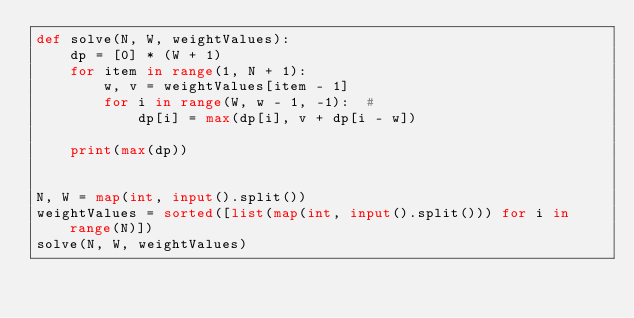<code> <loc_0><loc_0><loc_500><loc_500><_Python_>def solve(N, W, weightValues):
    dp = [0] * (W + 1)
    for item in range(1, N + 1):
        w, v = weightValues[item - 1]
        for i in range(W, w - 1, -1):  #
            dp[i] = max(dp[i], v + dp[i - w])

    print(max(dp))


N, W = map(int, input().split())
weightValues = sorted([list(map(int, input().split())) for i in range(N)])
solve(N, W, weightValues)</code> 